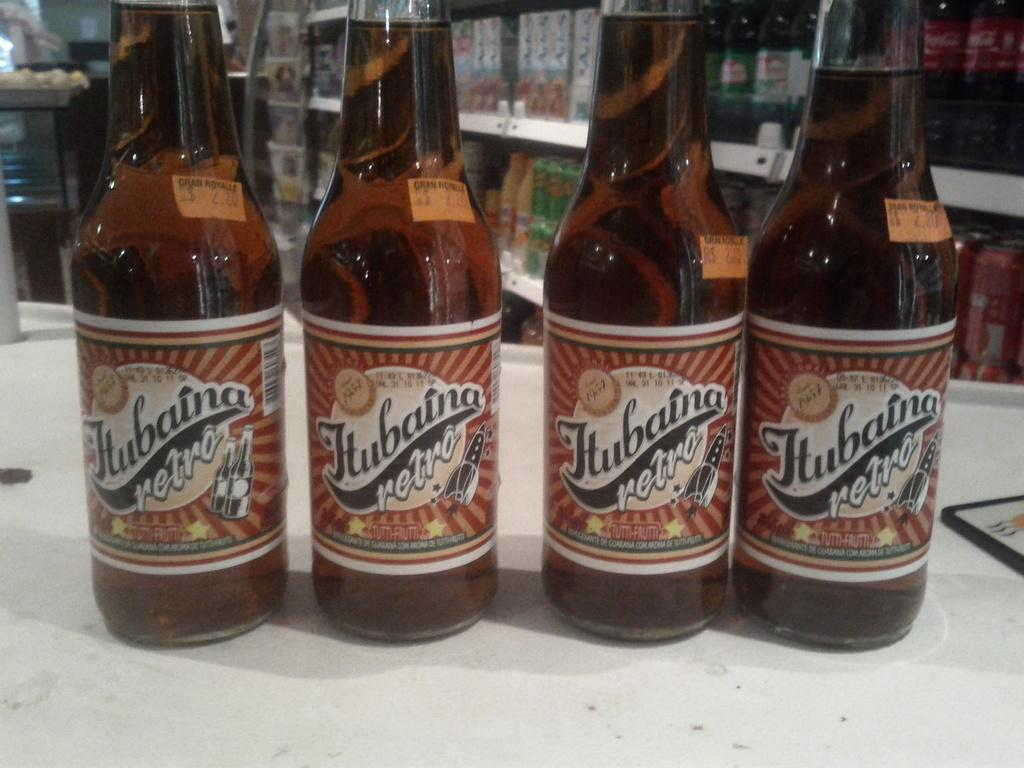<image>
Give a short and clear explanation of the subsequent image. Four, full bottles of Hubaina retro, with a price tag of $2.80 on them, are sitting in a row, on a counter. 